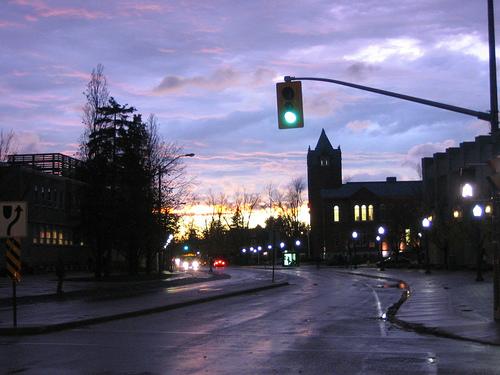Is this photo taken at night?
Be succinct. Yes. What color is the traffic light?
Be succinct. Green. What time of day is this?
Quick response, please. Evening. Is there any cars on the street?
Answer briefly. Yes. What types of trees are shown?
Answer briefly. Pine. 